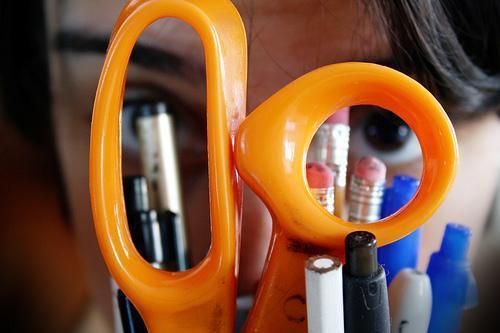Does the image validate the caption "The scissors is against the person."?
Answer yes or no. No. 